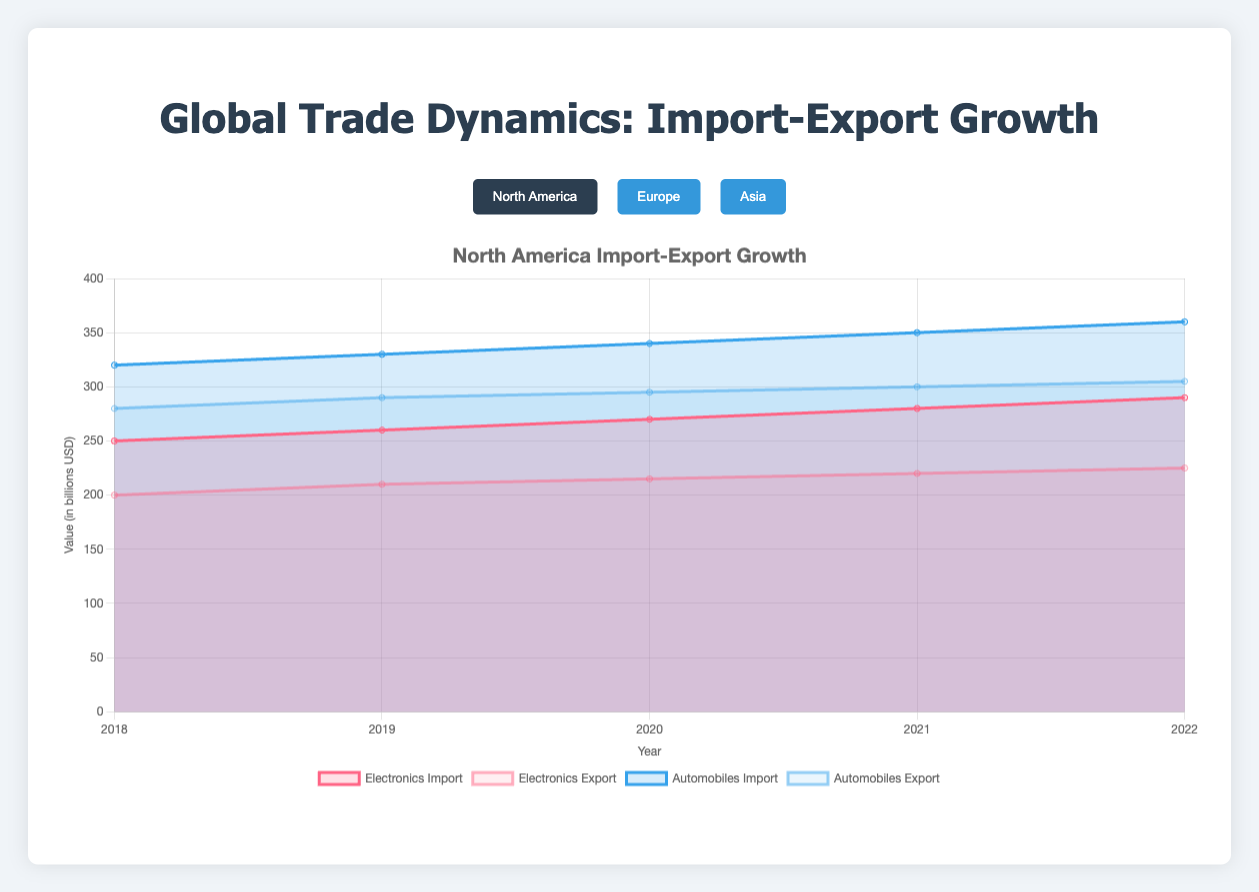What are the regions represented in the chart? The chart has a region selector allowing you to choose among North America, Europe, and Asia.
Answer: North America, Europe, Asia Which commodity has the highest export in Asia in 2022? Look at the "Asia" segment and check the export values for each commodity in 2022. Automobiles have the highest export value of 690 billion USD.
Answer: Automobiles How did the import of Electronics in North America change from 2018 to 2022? Refer to the "North America" section and observe the import values for Electronics over the years from 2018 to 2022: 250, 260, 270, 280, 290. There has been a consistent increase.
Answer: Increased What is the export growth rate for Automobiles in Europe from 2018 to 2022? Export values for Automobiles in Europe from 2018 to 2022 are: 350, 360, 370, 380, 390. The growth rate can be calculated as [(390 - 350) / 350] * 100 = approximately 11.43%.
Answer: 11.43% Which region has the highest total import value for Electronics in 2022? Compare the import values for Electronics in 2022 across all regions: North America (290), Europe (340), and Asia (540). Asia has the highest import value.
Answer: Asia How does the trend of automobile exports in North America compare to Europe from 2018 to 2022? Examine the export values for Automobiles in North America (280, 290, 295, 300, 305) and Europe (350, 360, 370, 380, 390) over the years. Both show an increasing trend, but Europe's values and growth are higher.
Answer: Europe's trend is higher and grows faster than North America's What is the combined export value of Electronics in North America and Europe in 2020? Find the export values for Electronics in North America (215) and Europe (265) for 2020. Then add them up: 215 + 265 = 480.
Answer: 480 In which year did the export of Electronics surpass its import in North America, if ever? Look at North America's Electronics import (250, 260, 270, 280, 290) and export (200, 210, 215, 220, 225) values. Exports never surpassed imports from 2018 to 2022.
Answer: Never What is the difference between export and import values for Automobiles in Asia in 2021? Refer to the 2021 values for Automobiles in Asia: Import - 730, Export - 680. The difference is 730 - 680 = 50.
Answer: 50 